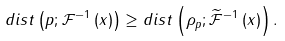<formula> <loc_0><loc_0><loc_500><loc_500>d i s t \left ( p ; \mathcal { F } ^ { - 1 } \left ( x \right ) \right ) \geq d i s t \left ( \rho _ { p } ; \widetilde { \mathcal { F } } ^ { - 1 } \left ( x \right ) \right ) .</formula> 